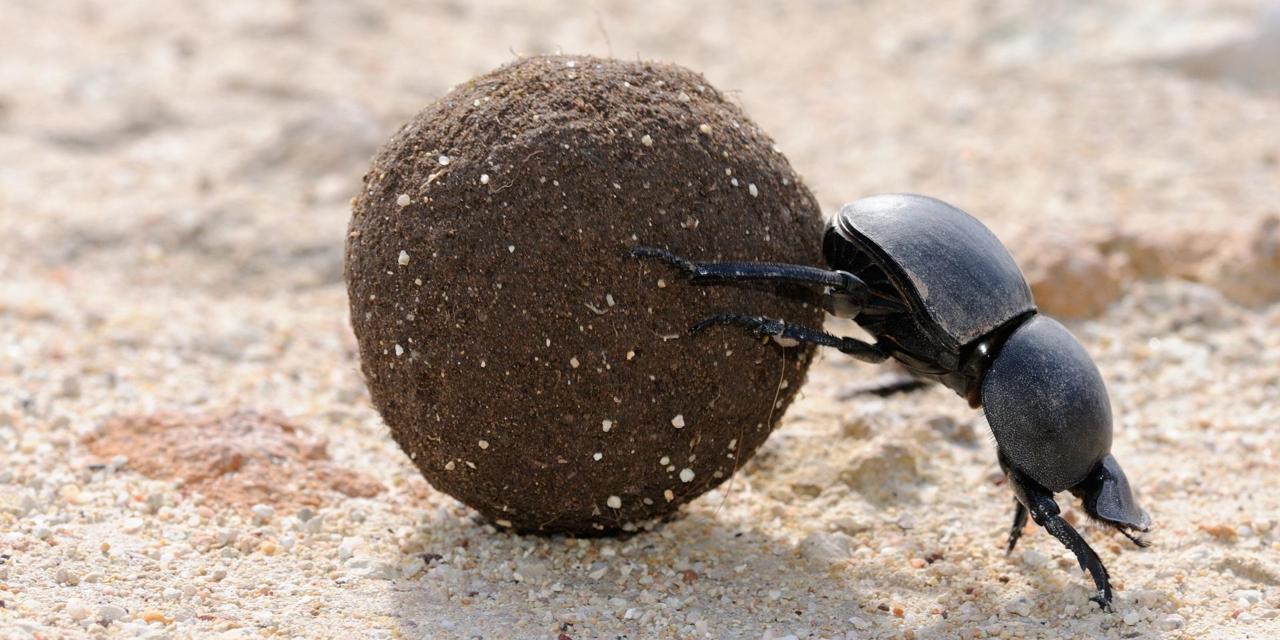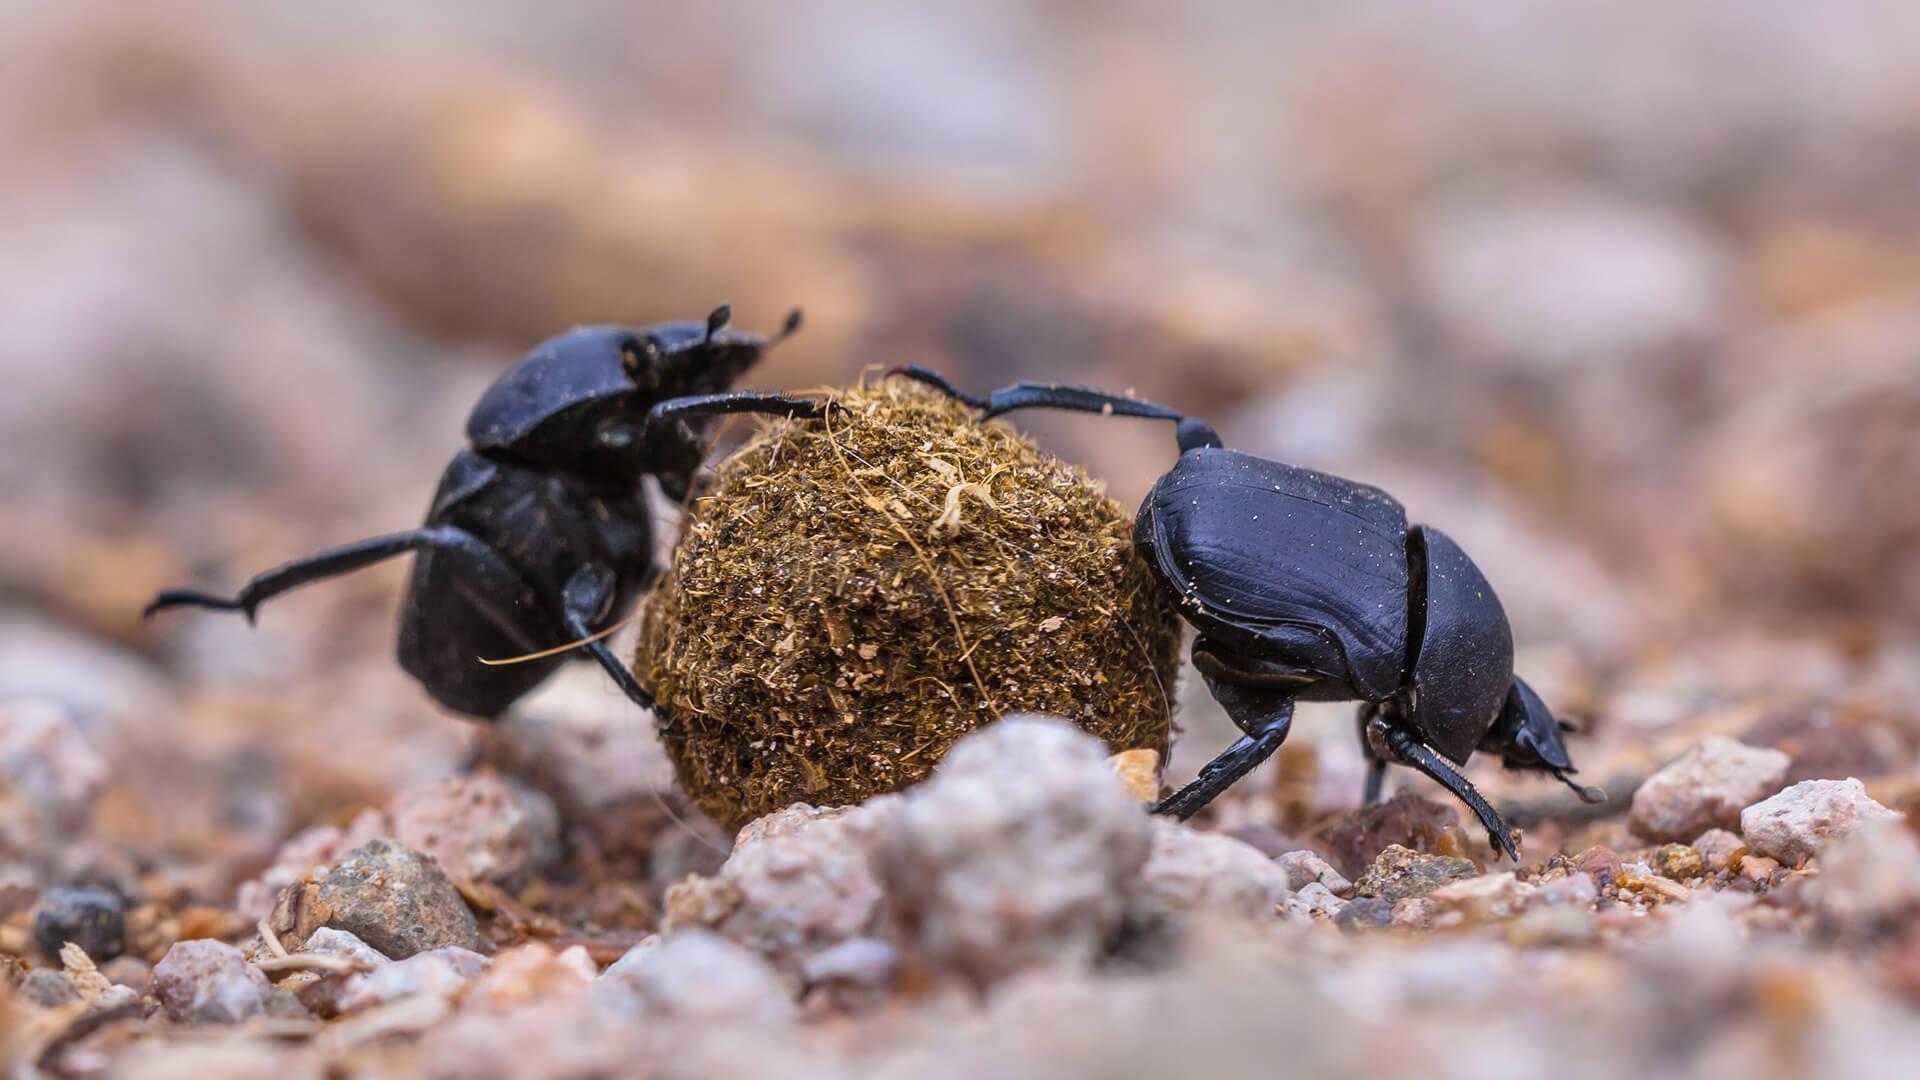The first image is the image on the left, the second image is the image on the right. For the images shown, is this caption "An image shows beetles on the left and right of one dungball, and each beetle is in contact with the ball." true? Answer yes or no. Yes. The first image is the image on the left, the second image is the image on the right. Given the left and right images, does the statement "There are only two beetles touching a dungball in the right image" hold true? Answer yes or no. Yes. 